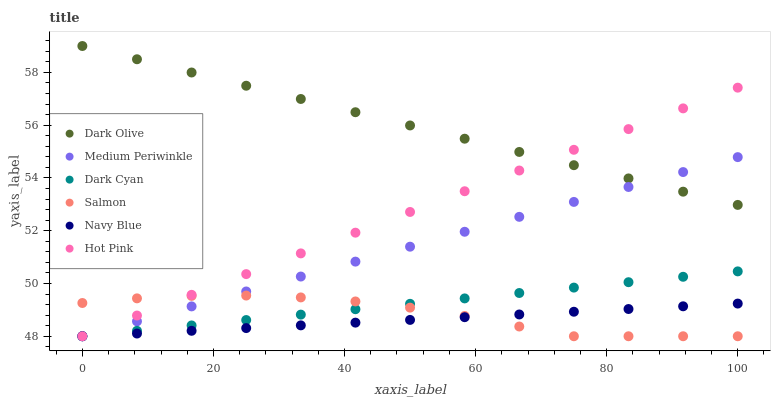Does Navy Blue have the minimum area under the curve?
Answer yes or no. Yes. Does Dark Olive have the maximum area under the curve?
Answer yes or no. Yes. Does Medium Periwinkle have the minimum area under the curve?
Answer yes or no. No. Does Medium Periwinkle have the maximum area under the curve?
Answer yes or no. No. Is Navy Blue the smoothest?
Answer yes or no. Yes. Is Salmon the roughest?
Answer yes or no. Yes. Is Medium Periwinkle the smoothest?
Answer yes or no. No. Is Medium Periwinkle the roughest?
Answer yes or no. No. Does Medium Periwinkle have the lowest value?
Answer yes or no. Yes. Does Dark Olive have the highest value?
Answer yes or no. Yes. Does Medium Periwinkle have the highest value?
Answer yes or no. No. Is Navy Blue less than Dark Olive?
Answer yes or no. Yes. Is Dark Olive greater than Dark Cyan?
Answer yes or no. Yes. Does Medium Periwinkle intersect Navy Blue?
Answer yes or no. Yes. Is Medium Periwinkle less than Navy Blue?
Answer yes or no. No. Is Medium Periwinkle greater than Navy Blue?
Answer yes or no. No. Does Navy Blue intersect Dark Olive?
Answer yes or no. No. 